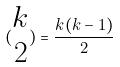<formula> <loc_0><loc_0><loc_500><loc_500>( \begin{matrix} k \\ 2 \end{matrix} ) = \frac { k ( k - 1 ) } { 2 }</formula> 